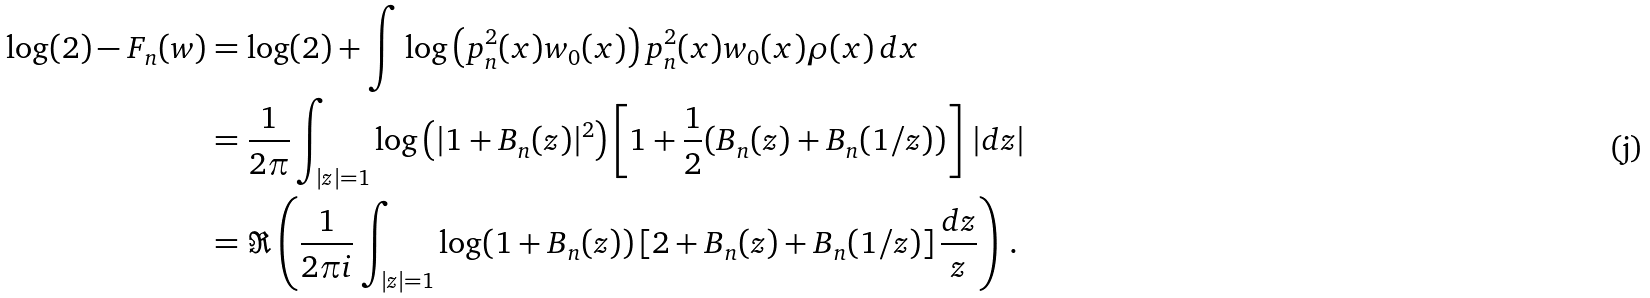Convert formula to latex. <formula><loc_0><loc_0><loc_500><loc_500>\log ( 2 ) - F _ { n } ( w ) & = \log ( 2 ) + \int \log \left ( p _ { n } ^ { 2 } ( x ) w _ { 0 } ( x ) \right ) p _ { n } ^ { 2 } ( x ) w _ { 0 } ( x ) \rho ( x ) \, d x \\ & = \frac { 1 } { 2 \pi } \int _ { | z | = 1 } \log \left ( | 1 + B _ { n } ( z ) | ^ { 2 } \right ) \left [ 1 + \frac { 1 } { 2 } ( B _ { n } ( z ) + B _ { n } ( 1 / z ) ) \right ] \, | d z | \\ & = \Re \left ( \frac { 1 } { 2 \pi i } \int _ { | z | = 1 } \log ( 1 + B _ { n } ( z ) ) \, [ 2 + B _ { n } ( z ) + B _ { n } ( 1 / z ) ] \, \frac { d z } { z } \right ) \, .</formula> 